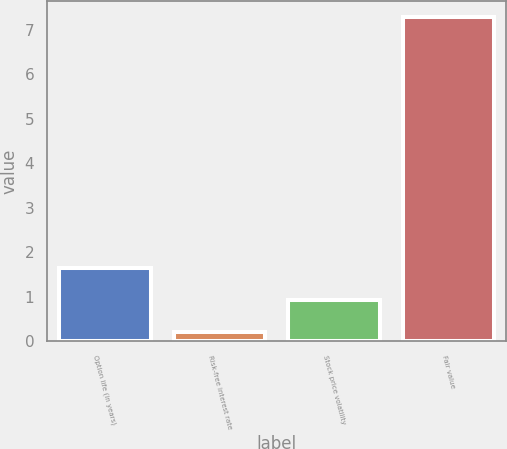<chart> <loc_0><loc_0><loc_500><loc_500><bar_chart><fcel>Option life (in years)<fcel>Risk-free interest rate<fcel>Stock price volatility<fcel>Fair value<nl><fcel>1.64<fcel>0.22<fcel>0.93<fcel>7.29<nl></chart> 